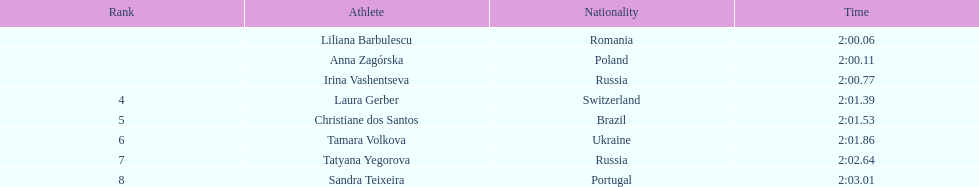What is the name of the highest-ranking finalist in this semifinals round? Liliana Barbulescu. 